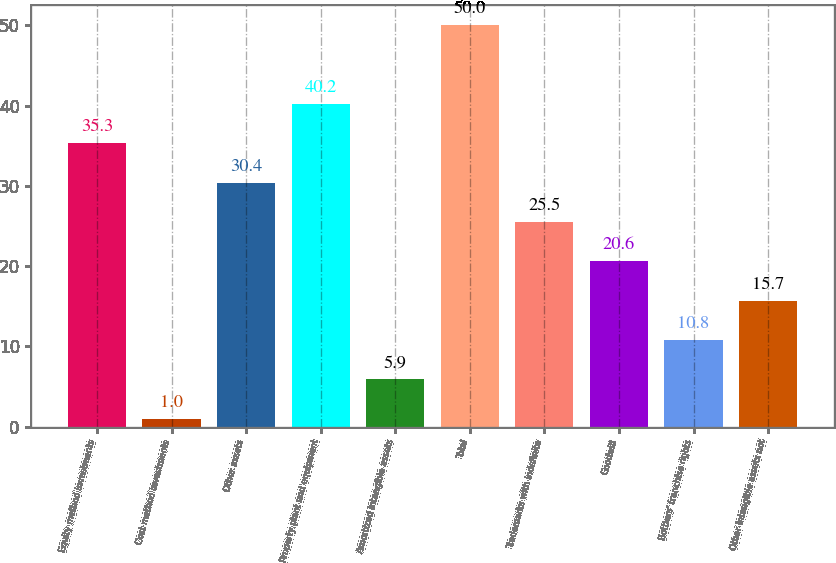Convert chart to OTSL. <chart><loc_0><loc_0><loc_500><loc_500><bar_chart><fcel>Equity method investments<fcel>Cost method investments<fcel>Other assets<fcel>Property plant and equipment<fcel>Amortized intangible assets<fcel>Total<fcel>Trademarks with indefinite<fcel>Goodwill<fcel>Bottlers' franchise rights<fcel>Other intangible assets not<nl><fcel>35.3<fcel>1<fcel>30.4<fcel>40.2<fcel>5.9<fcel>50<fcel>25.5<fcel>20.6<fcel>10.8<fcel>15.7<nl></chart> 